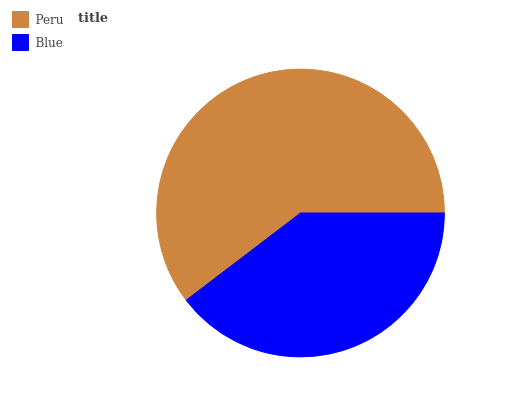Is Blue the minimum?
Answer yes or no. Yes. Is Peru the maximum?
Answer yes or no. Yes. Is Blue the maximum?
Answer yes or no. No. Is Peru greater than Blue?
Answer yes or no. Yes. Is Blue less than Peru?
Answer yes or no. Yes. Is Blue greater than Peru?
Answer yes or no. No. Is Peru less than Blue?
Answer yes or no. No. Is Peru the high median?
Answer yes or no. Yes. Is Blue the low median?
Answer yes or no. Yes. Is Blue the high median?
Answer yes or no. No. Is Peru the low median?
Answer yes or no. No. 